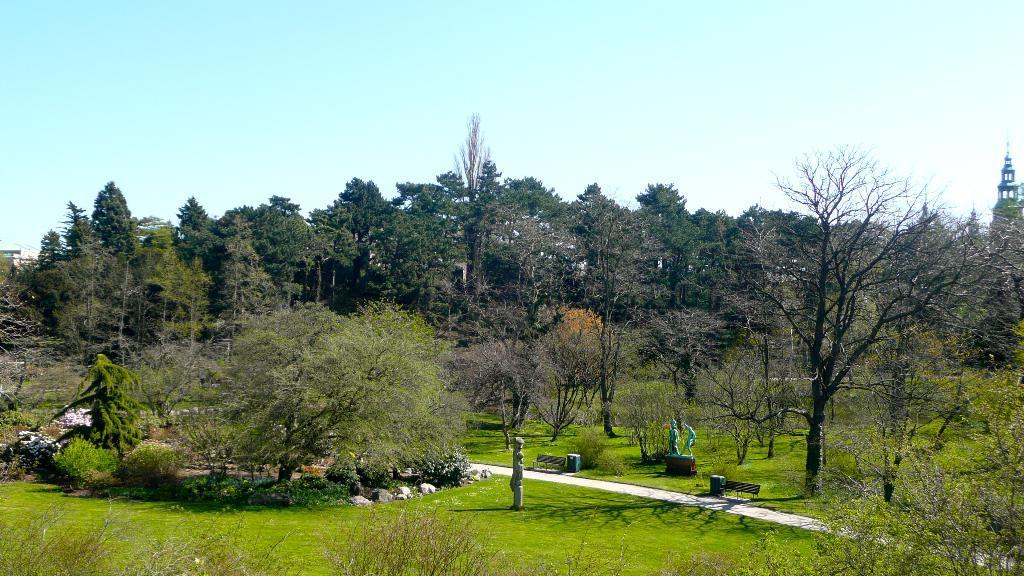Please provide a concise description of this image. In this image there is sky, there is a building truncated towards the right of the image, there are trees, there is grass, there are plants, there is a sculptor, there are benches, there are waste containers. 